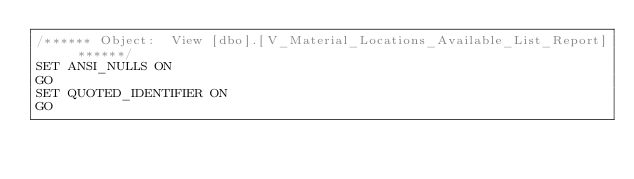<code> <loc_0><loc_0><loc_500><loc_500><_SQL_>/****** Object:  View [dbo].[V_Material_Locations_Available_List_Report] ******/
SET ANSI_NULLS ON
GO
SET QUOTED_IDENTIFIER ON
GO
</code> 